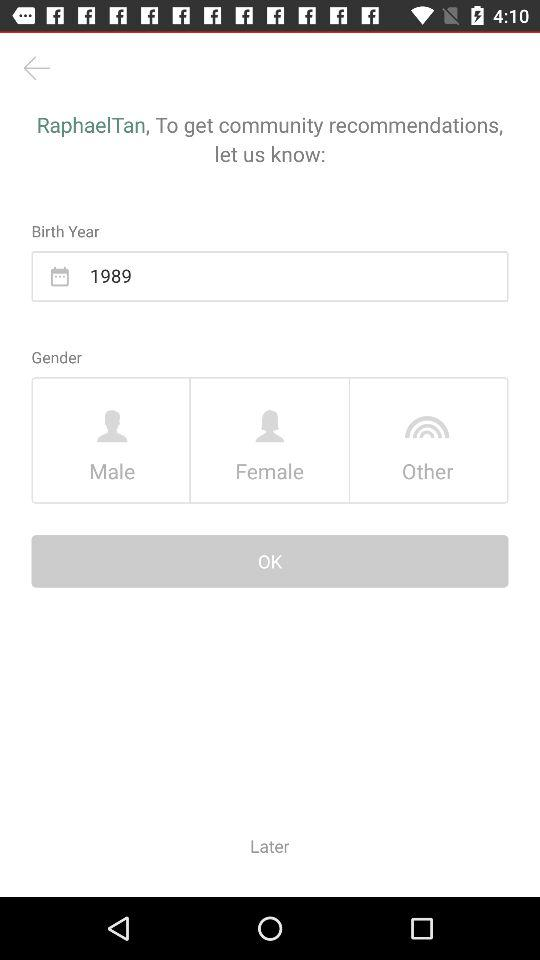What is the birth year? The birth year is 1989. 